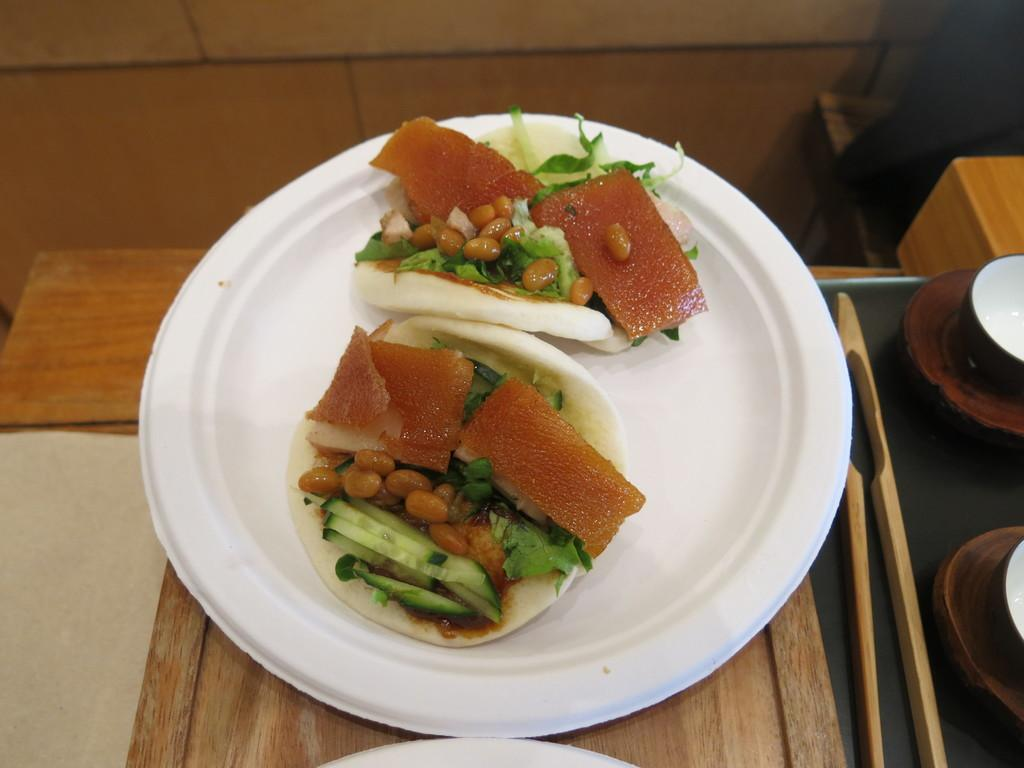What is on the plate that is visible in the image? There is a food item on the plate in the image. What else can be seen on the table in the image? There are objects on the table in the image. How many fingers can be seen holding the food item in the image? There are no fingers visible in the image, as it only shows a plate with a food item and objects on the table. 